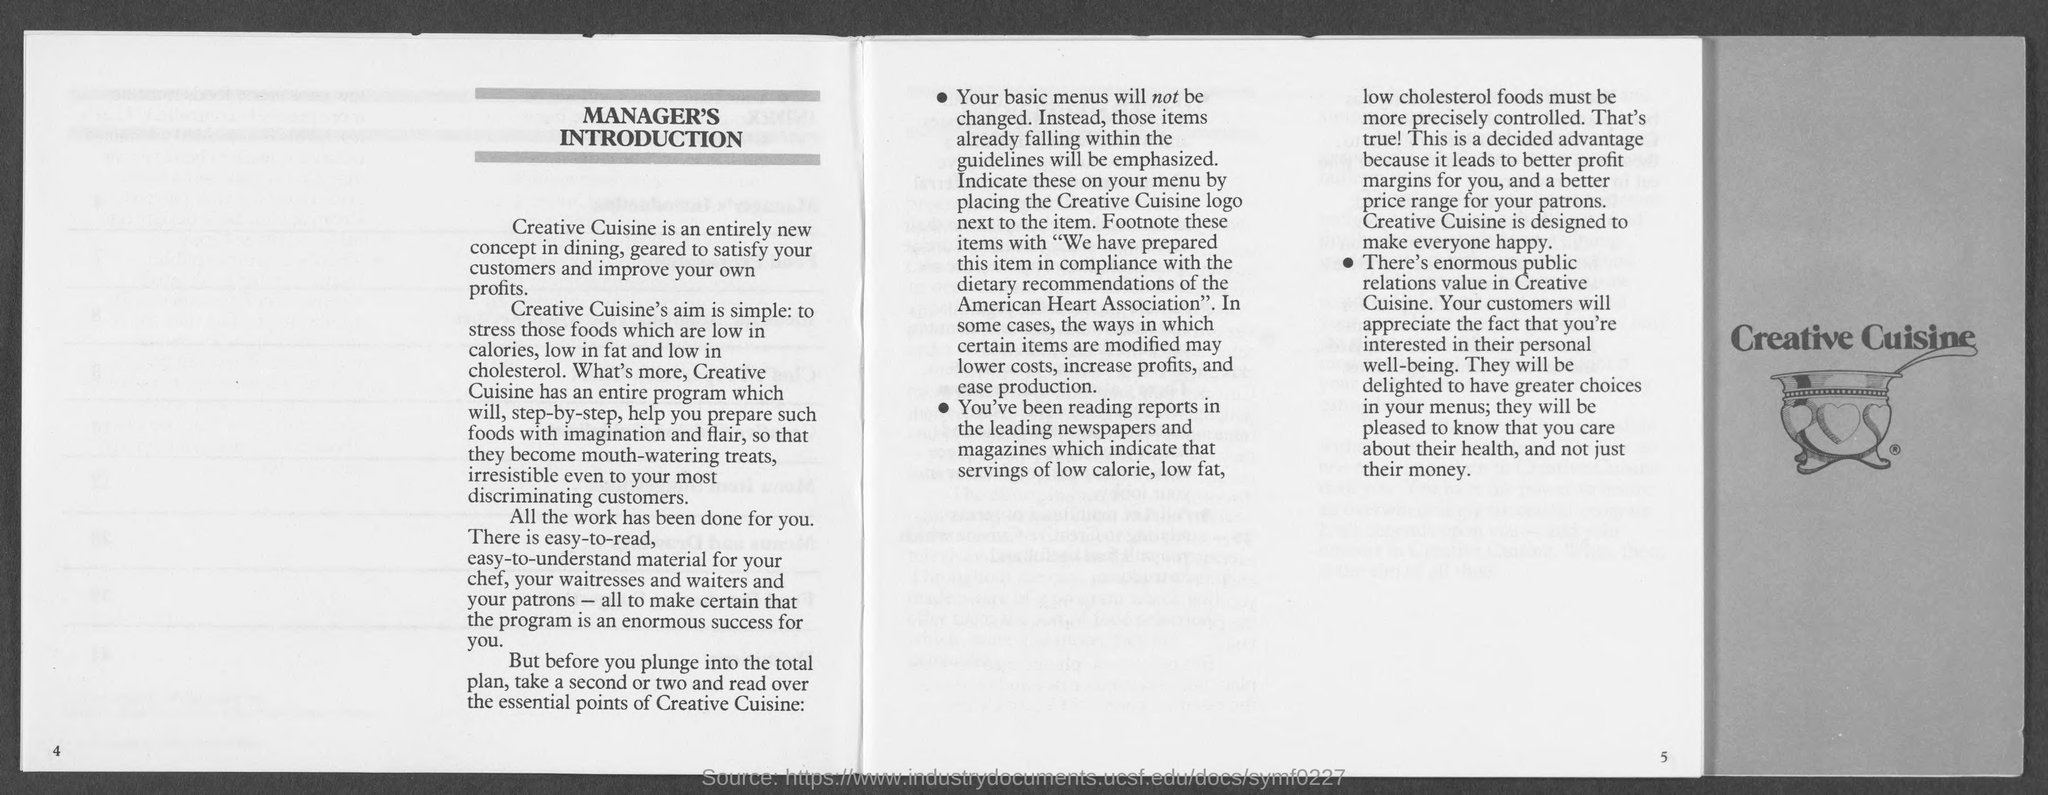Which is the association for dietary recommendations?
Offer a terse response. American Heart association. 